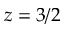<formula> <loc_0><loc_0><loc_500><loc_500>z = 3 / 2</formula> 